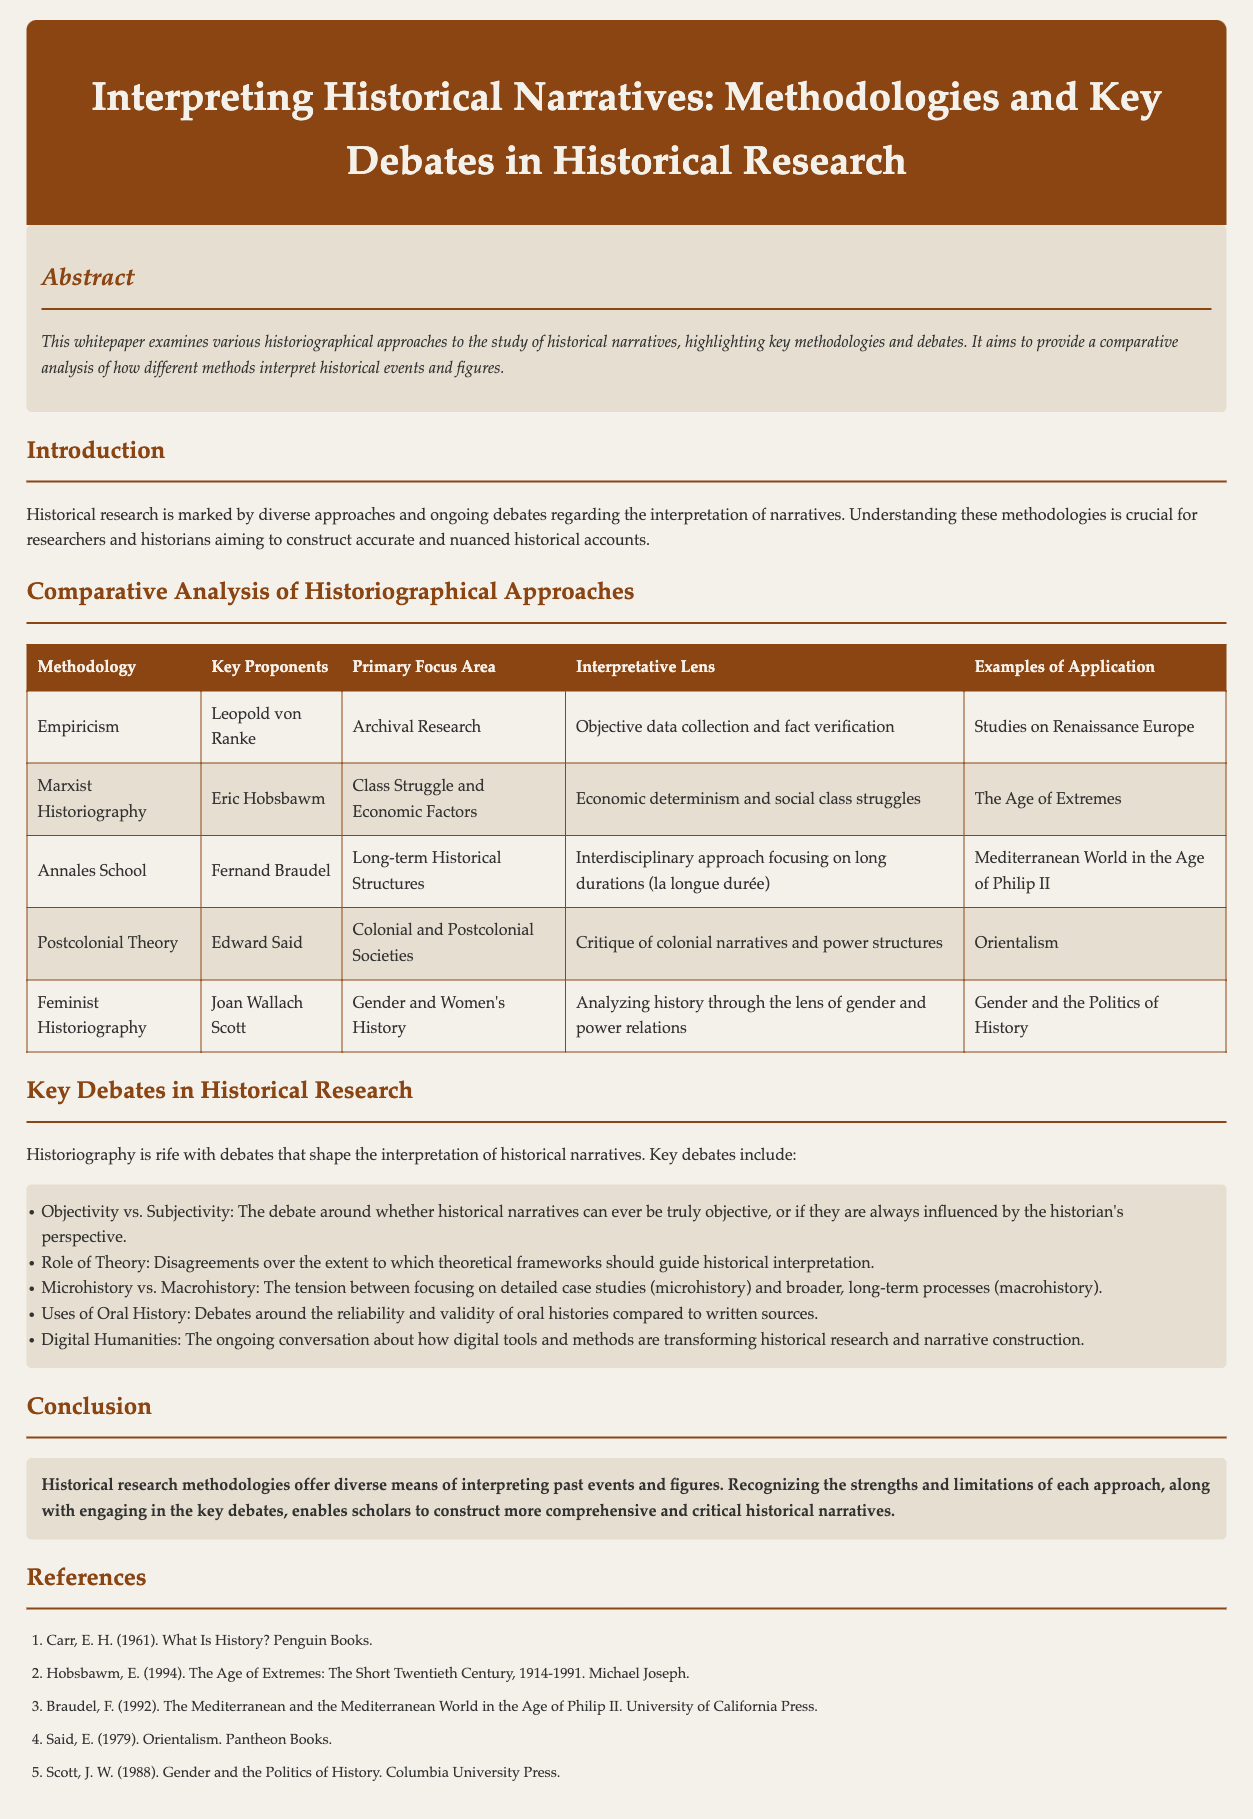What is the title of the whitepaper? The title is the heading of the document, which is prominently displayed at the top.
Answer: Interpreting Historical Narratives: Methodologies and Key Debates in Historical Research Who is a key proponent of the Annales School methodology? The key proponents are listed in the comparative analysis table under the corresponding methodology.
Answer: Fernand Braudel What area does Feminist Historiography focus on? The primary focus area is described in the comparative analysis table for Feminist Historiography.
Answer: Gender and Women's History What debate concerns the reliability of oral histories? This debate is mentioned in the section discussing key debates in historical research, highlighting different viewpoints.
Answer: Uses of Oral History What is the primary focus area of Empiricism? The primary focus area is listed in the comparative analysis table under Empiricism.
Answer: Archival Research 